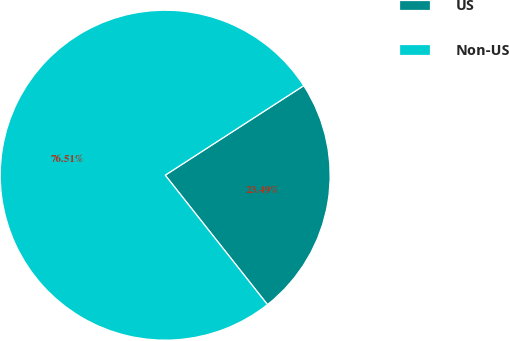<chart> <loc_0><loc_0><loc_500><loc_500><pie_chart><fcel>US<fcel>Non-US<nl><fcel>23.49%<fcel>76.51%<nl></chart> 